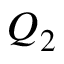<formula> <loc_0><loc_0><loc_500><loc_500>Q _ { 2 }</formula> 